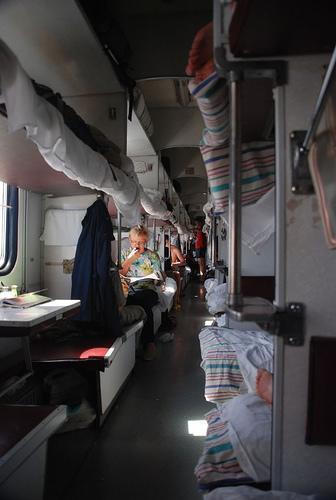How many people are in the photo?
Give a very brief answer. 3. How many benches are visible?
Give a very brief answer. 2. How many beds are visible?
Give a very brief answer. 3. How many glass cups have water in them?
Give a very brief answer. 0. 